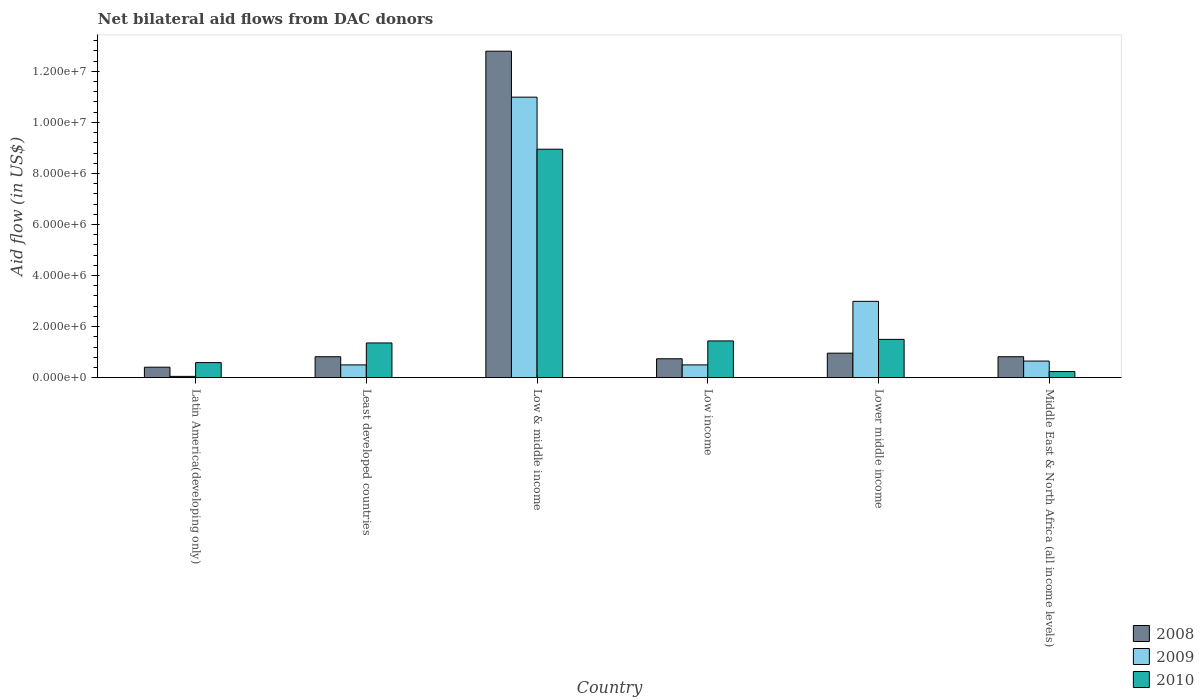How many different coloured bars are there?
Make the answer very short. 3. How many groups of bars are there?
Keep it short and to the point. 6. Are the number of bars per tick equal to the number of legend labels?
Provide a succinct answer. Yes. How many bars are there on the 2nd tick from the right?
Offer a terse response. 3. In how many cases, is the number of bars for a given country not equal to the number of legend labels?
Your answer should be compact. 0. What is the net bilateral aid flow in 2008 in Low & middle income?
Your answer should be very brief. 1.28e+07. Across all countries, what is the maximum net bilateral aid flow in 2009?
Make the answer very short. 1.10e+07. Across all countries, what is the minimum net bilateral aid flow in 2010?
Your answer should be very brief. 2.40e+05. In which country was the net bilateral aid flow in 2010 minimum?
Offer a terse response. Middle East & North Africa (all income levels). What is the total net bilateral aid flow in 2009 in the graph?
Ensure brevity in your answer.  1.57e+07. What is the difference between the net bilateral aid flow in 2008 in Low & middle income and the net bilateral aid flow in 2009 in Low income?
Your response must be concise. 1.23e+07. What is the average net bilateral aid flow in 2010 per country?
Give a very brief answer. 2.35e+06. What is the ratio of the net bilateral aid flow in 2010 in Latin America(developing only) to that in Least developed countries?
Offer a terse response. 0.43. Is the net bilateral aid flow in 2008 in Low & middle income less than that in Low income?
Your answer should be compact. No. What is the difference between the highest and the second highest net bilateral aid flow in 2009?
Ensure brevity in your answer.  1.03e+07. What is the difference between the highest and the lowest net bilateral aid flow in 2009?
Offer a very short reply. 1.09e+07. In how many countries, is the net bilateral aid flow in 2008 greater than the average net bilateral aid flow in 2008 taken over all countries?
Your response must be concise. 1. What does the 2nd bar from the left in Latin America(developing only) represents?
Your answer should be compact. 2009. How many bars are there?
Your response must be concise. 18. Are the values on the major ticks of Y-axis written in scientific E-notation?
Offer a very short reply. Yes. Does the graph contain any zero values?
Provide a succinct answer. No. Does the graph contain grids?
Your answer should be very brief. No. Where does the legend appear in the graph?
Offer a terse response. Bottom right. How many legend labels are there?
Ensure brevity in your answer.  3. What is the title of the graph?
Give a very brief answer. Net bilateral aid flows from DAC donors. What is the label or title of the Y-axis?
Provide a short and direct response. Aid flow (in US$). What is the Aid flow (in US$) of 2010 in Latin America(developing only)?
Keep it short and to the point. 5.90e+05. What is the Aid flow (in US$) of 2008 in Least developed countries?
Your answer should be compact. 8.20e+05. What is the Aid flow (in US$) in 2009 in Least developed countries?
Your answer should be very brief. 5.00e+05. What is the Aid flow (in US$) in 2010 in Least developed countries?
Your answer should be very brief. 1.36e+06. What is the Aid flow (in US$) in 2008 in Low & middle income?
Make the answer very short. 1.28e+07. What is the Aid flow (in US$) of 2009 in Low & middle income?
Keep it short and to the point. 1.10e+07. What is the Aid flow (in US$) of 2010 in Low & middle income?
Provide a succinct answer. 8.95e+06. What is the Aid flow (in US$) in 2008 in Low income?
Your answer should be compact. 7.40e+05. What is the Aid flow (in US$) of 2009 in Low income?
Your answer should be very brief. 5.00e+05. What is the Aid flow (in US$) of 2010 in Low income?
Keep it short and to the point. 1.44e+06. What is the Aid flow (in US$) in 2008 in Lower middle income?
Your response must be concise. 9.60e+05. What is the Aid flow (in US$) of 2009 in Lower middle income?
Give a very brief answer. 2.99e+06. What is the Aid flow (in US$) in 2010 in Lower middle income?
Offer a very short reply. 1.50e+06. What is the Aid flow (in US$) of 2008 in Middle East & North Africa (all income levels)?
Your answer should be compact. 8.20e+05. What is the Aid flow (in US$) in 2009 in Middle East & North Africa (all income levels)?
Ensure brevity in your answer.  6.50e+05. What is the Aid flow (in US$) of 2010 in Middle East & North Africa (all income levels)?
Give a very brief answer. 2.40e+05. Across all countries, what is the maximum Aid flow (in US$) of 2008?
Your answer should be very brief. 1.28e+07. Across all countries, what is the maximum Aid flow (in US$) of 2009?
Keep it short and to the point. 1.10e+07. Across all countries, what is the maximum Aid flow (in US$) of 2010?
Give a very brief answer. 8.95e+06. Across all countries, what is the minimum Aid flow (in US$) of 2008?
Your answer should be very brief. 4.10e+05. Across all countries, what is the minimum Aid flow (in US$) in 2009?
Give a very brief answer. 5.00e+04. What is the total Aid flow (in US$) of 2008 in the graph?
Provide a short and direct response. 1.65e+07. What is the total Aid flow (in US$) of 2009 in the graph?
Offer a terse response. 1.57e+07. What is the total Aid flow (in US$) in 2010 in the graph?
Offer a very short reply. 1.41e+07. What is the difference between the Aid flow (in US$) of 2008 in Latin America(developing only) and that in Least developed countries?
Give a very brief answer. -4.10e+05. What is the difference between the Aid flow (in US$) in 2009 in Latin America(developing only) and that in Least developed countries?
Give a very brief answer. -4.50e+05. What is the difference between the Aid flow (in US$) of 2010 in Latin America(developing only) and that in Least developed countries?
Make the answer very short. -7.70e+05. What is the difference between the Aid flow (in US$) in 2008 in Latin America(developing only) and that in Low & middle income?
Ensure brevity in your answer.  -1.24e+07. What is the difference between the Aid flow (in US$) in 2009 in Latin America(developing only) and that in Low & middle income?
Your response must be concise. -1.09e+07. What is the difference between the Aid flow (in US$) of 2010 in Latin America(developing only) and that in Low & middle income?
Offer a terse response. -8.36e+06. What is the difference between the Aid flow (in US$) in 2008 in Latin America(developing only) and that in Low income?
Make the answer very short. -3.30e+05. What is the difference between the Aid flow (in US$) in 2009 in Latin America(developing only) and that in Low income?
Offer a very short reply. -4.50e+05. What is the difference between the Aid flow (in US$) of 2010 in Latin America(developing only) and that in Low income?
Offer a very short reply. -8.50e+05. What is the difference between the Aid flow (in US$) in 2008 in Latin America(developing only) and that in Lower middle income?
Offer a terse response. -5.50e+05. What is the difference between the Aid flow (in US$) in 2009 in Latin America(developing only) and that in Lower middle income?
Give a very brief answer. -2.94e+06. What is the difference between the Aid flow (in US$) of 2010 in Latin America(developing only) and that in Lower middle income?
Offer a very short reply. -9.10e+05. What is the difference between the Aid flow (in US$) in 2008 in Latin America(developing only) and that in Middle East & North Africa (all income levels)?
Your response must be concise. -4.10e+05. What is the difference between the Aid flow (in US$) of 2009 in Latin America(developing only) and that in Middle East & North Africa (all income levels)?
Keep it short and to the point. -6.00e+05. What is the difference between the Aid flow (in US$) in 2010 in Latin America(developing only) and that in Middle East & North Africa (all income levels)?
Provide a succinct answer. 3.50e+05. What is the difference between the Aid flow (in US$) in 2008 in Least developed countries and that in Low & middle income?
Keep it short and to the point. -1.20e+07. What is the difference between the Aid flow (in US$) of 2009 in Least developed countries and that in Low & middle income?
Offer a terse response. -1.05e+07. What is the difference between the Aid flow (in US$) of 2010 in Least developed countries and that in Low & middle income?
Give a very brief answer. -7.59e+06. What is the difference between the Aid flow (in US$) in 2009 in Least developed countries and that in Low income?
Make the answer very short. 0. What is the difference between the Aid flow (in US$) of 2008 in Least developed countries and that in Lower middle income?
Provide a short and direct response. -1.40e+05. What is the difference between the Aid flow (in US$) in 2009 in Least developed countries and that in Lower middle income?
Provide a short and direct response. -2.49e+06. What is the difference between the Aid flow (in US$) of 2010 in Least developed countries and that in Lower middle income?
Provide a succinct answer. -1.40e+05. What is the difference between the Aid flow (in US$) in 2008 in Least developed countries and that in Middle East & North Africa (all income levels)?
Make the answer very short. 0. What is the difference between the Aid flow (in US$) in 2009 in Least developed countries and that in Middle East & North Africa (all income levels)?
Make the answer very short. -1.50e+05. What is the difference between the Aid flow (in US$) of 2010 in Least developed countries and that in Middle East & North Africa (all income levels)?
Provide a succinct answer. 1.12e+06. What is the difference between the Aid flow (in US$) in 2008 in Low & middle income and that in Low income?
Provide a short and direct response. 1.20e+07. What is the difference between the Aid flow (in US$) in 2009 in Low & middle income and that in Low income?
Offer a terse response. 1.05e+07. What is the difference between the Aid flow (in US$) of 2010 in Low & middle income and that in Low income?
Keep it short and to the point. 7.51e+06. What is the difference between the Aid flow (in US$) in 2008 in Low & middle income and that in Lower middle income?
Give a very brief answer. 1.18e+07. What is the difference between the Aid flow (in US$) of 2009 in Low & middle income and that in Lower middle income?
Offer a terse response. 8.00e+06. What is the difference between the Aid flow (in US$) of 2010 in Low & middle income and that in Lower middle income?
Keep it short and to the point. 7.45e+06. What is the difference between the Aid flow (in US$) in 2008 in Low & middle income and that in Middle East & North Africa (all income levels)?
Keep it short and to the point. 1.20e+07. What is the difference between the Aid flow (in US$) in 2009 in Low & middle income and that in Middle East & North Africa (all income levels)?
Offer a very short reply. 1.03e+07. What is the difference between the Aid flow (in US$) of 2010 in Low & middle income and that in Middle East & North Africa (all income levels)?
Ensure brevity in your answer.  8.71e+06. What is the difference between the Aid flow (in US$) of 2009 in Low income and that in Lower middle income?
Make the answer very short. -2.49e+06. What is the difference between the Aid flow (in US$) of 2010 in Low income and that in Lower middle income?
Provide a succinct answer. -6.00e+04. What is the difference between the Aid flow (in US$) of 2010 in Low income and that in Middle East & North Africa (all income levels)?
Your answer should be very brief. 1.20e+06. What is the difference between the Aid flow (in US$) in 2009 in Lower middle income and that in Middle East & North Africa (all income levels)?
Offer a very short reply. 2.34e+06. What is the difference between the Aid flow (in US$) of 2010 in Lower middle income and that in Middle East & North Africa (all income levels)?
Your answer should be very brief. 1.26e+06. What is the difference between the Aid flow (in US$) of 2008 in Latin America(developing only) and the Aid flow (in US$) of 2010 in Least developed countries?
Give a very brief answer. -9.50e+05. What is the difference between the Aid flow (in US$) of 2009 in Latin America(developing only) and the Aid flow (in US$) of 2010 in Least developed countries?
Your answer should be very brief. -1.31e+06. What is the difference between the Aid flow (in US$) in 2008 in Latin America(developing only) and the Aid flow (in US$) in 2009 in Low & middle income?
Make the answer very short. -1.06e+07. What is the difference between the Aid flow (in US$) of 2008 in Latin America(developing only) and the Aid flow (in US$) of 2010 in Low & middle income?
Your answer should be very brief. -8.54e+06. What is the difference between the Aid flow (in US$) of 2009 in Latin America(developing only) and the Aid flow (in US$) of 2010 in Low & middle income?
Offer a terse response. -8.90e+06. What is the difference between the Aid flow (in US$) of 2008 in Latin America(developing only) and the Aid flow (in US$) of 2009 in Low income?
Keep it short and to the point. -9.00e+04. What is the difference between the Aid flow (in US$) of 2008 in Latin America(developing only) and the Aid flow (in US$) of 2010 in Low income?
Offer a very short reply. -1.03e+06. What is the difference between the Aid flow (in US$) of 2009 in Latin America(developing only) and the Aid flow (in US$) of 2010 in Low income?
Offer a very short reply. -1.39e+06. What is the difference between the Aid flow (in US$) in 2008 in Latin America(developing only) and the Aid flow (in US$) in 2009 in Lower middle income?
Provide a succinct answer. -2.58e+06. What is the difference between the Aid flow (in US$) of 2008 in Latin America(developing only) and the Aid flow (in US$) of 2010 in Lower middle income?
Make the answer very short. -1.09e+06. What is the difference between the Aid flow (in US$) in 2009 in Latin America(developing only) and the Aid flow (in US$) in 2010 in Lower middle income?
Give a very brief answer. -1.45e+06. What is the difference between the Aid flow (in US$) in 2008 in Least developed countries and the Aid flow (in US$) in 2009 in Low & middle income?
Provide a succinct answer. -1.02e+07. What is the difference between the Aid flow (in US$) in 2008 in Least developed countries and the Aid flow (in US$) in 2010 in Low & middle income?
Offer a terse response. -8.13e+06. What is the difference between the Aid flow (in US$) of 2009 in Least developed countries and the Aid flow (in US$) of 2010 in Low & middle income?
Ensure brevity in your answer.  -8.45e+06. What is the difference between the Aid flow (in US$) of 2008 in Least developed countries and the Aid flow (in US$) of 2009 in Low income?
Provide a succinct answer. 3.20e+05. What is the difference between the Aid flow (in US$) in 2008 in Least developed countries and the Aid flow (in US$) in 2010 in Low income?
Offer a terse response. -6.20e+05. What is the difference between the Aid flow (in US$) in 2009 in Least developed countries and the Aid flow (in US$) in 2010 in Low income?
Provide a short and direct response. -9.40e+05. What is the difference between the Aid flow (in US$) of 2008 in Least developed countries and the Aid flow (in US$) of 2009 in Lower middle income?
Offer a terse response. -2.17e+06. What is the difference between the Aid flow (in US$) in 2008 in Least developed countries and the Aid flow (in US$) in 2010 in Lower middle income?
Make the answer very short. -6.80e+05. What is the difference between the Aid flow (in US$) in 2008 in Least developed countries and the Aid flow (in US$) in 2010 in Middle East & North Africa (all income levels)?
Keep it short and to the point. 5.80e+05. What is the difference between the Aid flow (in US$) in 2009 in Least developed countries and the Aid flow (in US$) in 2010 in Middle East & North Africa (all income levels)?
Offer a very short reply. 2.60e+05. What is the difference between the Aid flow (in US$) of 2008 in Low & middle income and the Aid flow (in US$) of 2009 in Low income?
Provide a short and direct response. 1.23e+07. What is the difference between the Aid flow (in US$) of 2008 in Low & middle income and the Aid flow (in US$) of 2010 in Low income?
Your answer should be very brief. 1.14e+07. What is the difference between the Aid flow (in US$) in 2009 in Low & middle income and the Aid flow (in US$) in 2010 in Low income?
Offer a terse response. 9.55e+06. What is the difference between the Aid flow (in US$) of 2008 in Low & middle income and the Aid flow (in US$) of 2009 in Lower middle income?
Ensure brevity in your answer.  9.80e+06. What is the difference between the Aid flow (in US$) of 2008 in Low & middle income and the Aid flow (in US$) of 2010 in Lower middle income?
Provide a short and direct response. 1.13e+07. What is the difference between the Aid flow (in US$) of 2009 in Low & middle income and the Aid flow (in US$) of 2010 in Lower middle income?
Make the answer very short. 9.49e+06. What is the difference between the Aid flow (in US$) of 2008 in Low & middle income and the Aid flow (in US$) of 2009 in Middle East & North Africa (all income levels)?
Your answer should be compact. 1.21e+07. What is the difference between the Aid flow (in US$) in 2008 in Low & middle income and the Aid flow (in US$) in 2010 in Middle East & North Africa (all income levels)?
Your response must be concise. 1.26e+07. What is the difference between the Aid flow (in US$) in 2009 in Low & middle income and the Aid flow (in US$) in 2010 in Middle East & North Africa (all income levels)?
Keep it short and to the point. 1.08e+07. What is the difference between the Aid flow (in US$) in 2008 in Low income and the Aid flow (in US$) in 2009 in Lower middle income?
Keep it short and to the point. -2.25e+06. What is the difference between the Aid flow (in US$) of 2008 in Low income and the Aid flow (in US$) of 2010 in Lower middle income?
Your answer should be compact. -7.60e+05. What is the difference between the Aid flow (in US$) of 2009 in Low income and the Aid flow (in US$) of 2010 in Lower middle income?
Give a very brief answer. -1.00e+06. What is the difference between the Aid flow (in US$) in 2008 in Low income and the Aid flow (in US$) in 2009 in Middle East & North Africa (all income levels)?
Ensure brevity in your answer.  9.00e+04. What is the difference between the Aid flow (in US$) in 2009 in Low income and the Aid flow (in US$) in 2010 in Middle East & North Africa (all income levels)?
Offer a very short reply. 2.60e+05. What is the difference between the Aid flow (in US$) of 2008 in Lower middle income and the Aid flow (in US$) of 2009 in Middle East & North Africa (all income levels)?
Ensure brevity in your answer.  3.10e+05. What is the difference between the Aid flow (in US$) of 2008 in Lower middle income and the Aid flow (in US$) of 2010 in Middle East & North Africa (all income levels)?
Provide a succinct answer. 7.20e+05. What is the difference between the Aid flow (in US$) in 2009 in Lower middle income and the Aid flow (in US$) in 2010 in Middle East & North Africa (all income levels)?
Give a very brief answer. 2.75e+06. What is the average Aid flow (in US$) in 2008 per country?
Your answer should be very brief. 2.76e+06. What is the average Aid flow (in US$) in 2009 per country?
Provide a succinct answer. 2.61e+06. What is the average Aid flow (in US$) in 2010 per country?
Make the answer very short. 2.35e+06. What is the difference between the Aid flow (in US$) in 2008 and Aid flow (in US$) in 2009 in Latin America(developing only)?
Your response must be concise. 3.60e+05. What is the difference between the Aid flow (in US$) of 2008 and Aid flow (in US$) of 2010 in Latin America(developing only)?
Give a very brief answer. -1.80e+05. What is the difference between the Aid flow (in US$) of 2009 and Aid flow (in US$) of 2010 in Latin America(developing only)?
Provide a short and direct response. -5.40e+05. What is the difference between the Aid flow (in US$) in 2008 and Aid flow (in US$) in 2010 in Least developed countries?
Your answer should be very brief. -5.40e+05. What is the difference between the Aid flow (in US$) in 2009 and Aid flow (in US$) in 2010 in Least developed countries?
Your response must be concise. -8.60e+05. What is the difference between the Aid flow (in US$) in 2008 and Aid flow (in US$) in 2009 in Low & middle income?
Ensure brevity in your answer.  1.80e+06. What is the difference between the Aid flow (in US$) in 2008 and Aid flow (in US$) in 2010 in Low & middle income?
Offer a terse response. 3.84e+06. What is the difference between the Aid flow (in US$) of 2009 and Aid flow (in US$) of 2010 in Low & middle income?
Your answer should be compact. 2.04e+06. What is the difference between the Aid flow (in US$) in 2008 and Aid flow (in US$) in 2009 in Low income?
Offer a terse response. 2.40e+05. What is the difference between the Aid flow (in US$) of 2008 and Aid flow (in US$) of 2010 in Low income?
Keep it short and to the point. -7.00e+05. What is the difference between the Aid flow (in US$) in 2009 and Aid flow (in US$) in 2010 in Low income?
Your answer should be compact. -9.40e+05. What is the difference between the Aid flow (in US$) of 2008 and Aid flow (in US$) of 2009 in Lower middle income?
Ensure brevity in your answer.  -2.03e+06. What is the difference between the Aid flow (in US$) in 2008 and Aid flow (in US$) in 2010 in Lower middle income?
Offer a terse response. -5.40e+05. What is the difference between the Aid flow (in US$) in 2009 and Aid flow (in US$) in 2010 in Lower middle income?
Offer a terse response. 1.49e+06. What is the difference between the Aid flow (in US$) of 2008 and Aid flow (in US$) of 2010 in Middle East & North Africa (all income levels)?
Keep it short and to the point. 5.80e+05. What is the ratio of the Aid flow (in US$) of 2008 in Latin America(developing only) to that in Least developed countries?
Your answer should be compact. 0.5. What is the ratio of the Aid flow (in US$) in 2009 in Latin America(developing only) to that in Least developed countries?
Provide a succinct answer. 0.1. What is the ratio of the Aid flow (in US$) in 2010 in Latin America(developing only) to that in Least developed countries?
Your response must be concise. 0.43. What is the ratio of the Aid flow (in US$) of 2008 in Latin America(developing only) to that in Low & middle income?
Your response must be concise. 0.03. What is the ratio of the Aid flow (in US$) of 2009 in Latin America(developing only) to that in Low & middle income?
Your answer should be compact. 0. What is the ratio of the Aid flow (in US$) in 2010 in Latin America(developing only) to that in Low & middle income?
Your answer should be compact. 0.07. What is the ratio of the Aid flow (in US$) in 2008 in Latin America(developing only) to that in Low income?
Make the answer very short. 0.55. What is the ratio of the Aid flow (in US$) in 2009 in Latin America(developing only) to that in Low income?
Provide a short and direct response. 0.1. What is the ratio of the Aid flow (in US$) in 2010 in Latin America(developing only) to that in Low income?
Your response must be concise. 0.41. What is the ratio of the Aid flow (in US$) of 2008 in Latin America(developing only) to that in Lower middle income?
Offer a very short reply. 0.43. What is the ratio of the Aid flow (in US$) in 2009 in Latin America(developing only) to that in Lower middle income?
Offer a very short reply. 0.02. What is the ratio of the Aid flow (in US$) of 2010 in Latin America(developing only) to that in Lower middle income?
Provide a succinct answer. 0.39. What is the ratio of the Aid flow (in US$) of 2009 in Latin America(developing only) to that in Middle East & North Africa (all income levels)?
Keep it short and to the point. 0.08. What is the ratio of the Aid flow (in US$) in 2010 in Latin America(developing only) to that in Middle East & North Africa (all income levels)?
Give a very brief answer. 2.46. What is the ratio of the Aid flow (in US$) in 2008 in Least developed countries to that in Low & middle income?
Your answer should be very brief. 0.06. What is the ratio of the Aid flow (in US$) of 2009 in Least developed countries to that in Low & middle income?
Your response must be concise. 0.05. What is the ratio of the Aid flow (in US$) of 2010 in Least developed countries to that in Low & middle income?
Your response must be concise. 0.15. What is the ratio of the Aid flow (in US$) of 2008 in Least developed countries to that in Low income?
Your answer should be compact. 1.11. What is the ratio of the Aid flow (in US$) of 2008 in Least developed countries to that in Lower middle income?
Provide a succinct answer. 0.85. What is the ratio of the Aid flow (in US$) in 2009 in Least developed countries to that in Lower middle income?
Make the answer very short. 0.17. What is the ratio of the Aid flow (in US$) in 2010 in Least developed countries to that in Lower middle income?
Your answer should be compact. 0.91. What is the ratio of the Aid flow (in US$) of 2008 in Least developed countries to that in Middle East & North Africa (all income levels)?
Offer a terse response. 1. What is the ratio of the Aid flow (in US$) of 2009 in Least developed countries to that in Middle East & North Africa (all income levels)?
Give a very brief answer. 0.77. What is the ratio of the Aid flow (in US$) in 2010 in Least developed countries to that in Middle East & North Africa (all income levels)?
Make the answer very short. 5.67. What is the ratio of the Aid flow (in US$) of 2008 in Low & middle income to that in Low income?
Offer a terse response. 17.28. What is the ratio of the Aid flow (in US$) in 2009 in Low & middle income to that in Low income?
Give a very brief answer. 21.98. What is the ratio of the Aid flow (in US$) in 2010 in Low & middle income to that in Low income?
Your answer should be very brief. 6.22. What is the ratio of the Aid flow (in US$) in 2008 in Low & middle income to that in Lower middle income?
Your response must be concise. 13.32. What is the ratio of the Aid flow (in US$) of 2009 in Low & middle income to that in Lower middle income?
Keep it short and to the point. 3.68. What is the ratio of the Aid flow (in US$) of 2010 in Low & middle income to that in Lower middle income?
Offer a terse response. 5.97. What is the ratio of the Aid flow (in US$) of 2008 in Low & middle income to that in Middle East & North Africa (all income levels)?
Offer a terse response. 15.6. What is the ratio of the Aid flow (in US$) of 2009 in Low & middle income to that in Middle East & North Africa (all income levels)?
Your response must be concise. 16.91. What is the ratio of the Aid flow (in US$) in 2010 in Low & middle income to that in Middle East & North Africa (all income levels)?
Provide a short and direct response. 37.29. What is the ratio of the Aid flow (in US$) in 2008 in Low income to that in Lower middle income?
Your response must be concise. 0.77. What is the ratio of the Aid flow (in US$) of 2009 in Low income to that in Lower middle income?
Your response must be concise. 0.17. What is the ratio of the Aid flow (in US$) of 2010 in Low income to that in Lower middle income?
Provide a short and direct response. 0.96. What is the ratio of the Aid flow (in US$) of 2008 in Low income to that in Middle East & North Africa (all income levels)?
Ensure brevity in your answer.  0.9. What is the ratio of the Aid flow (in US$) of 2009 in Low income to that in Middle East & North Africa (all income levels)?
Your response must be concise. 0.77. What is the ratio of the Aid flow (in US$) in 2010 in Low income to that in Middle East & North Africa (all income levels)?
Provide a short and direct response. 6. What is the ratio of the Aid flow (in US$) in 2008 in Lower middle income to that in Middle East & North Africa (all income levels)?
Offer a terse response. 1.17. What is the ratio of the Aid flow (in US$) of 2009 in Lower middle income to that in Middle East & North Africa (all income levels)?
Keep it short and to the point. 4.6. What is the ratio of the Aid flow (in US$) in 2010 in Lower middle income to that in Middle East & North Africa (all income levels)?
Your response must be concise. 6.25. What is the difference between the highest and the second highest Aid flow (in US$) in 2008?
Give a very brief answer. 1.18e+07. What is the difference between the highest and the second highest Aid flow (in US$) of 2010?
Offer a terse response. 7.45e+06. What is the difference between the highest and the lowest Aid flow (in US$) in 2008?
Offer a very short reply. 1.24e+07. What is the difference between the highest and the lowest Aid flow (in US$) of 2009?
Provide a short and direct response. 1.09e+07. What is the difference between the highest and the lowest Aid flow (in US$) in 2010?
Offer a very short reply. 8.71e+06. 